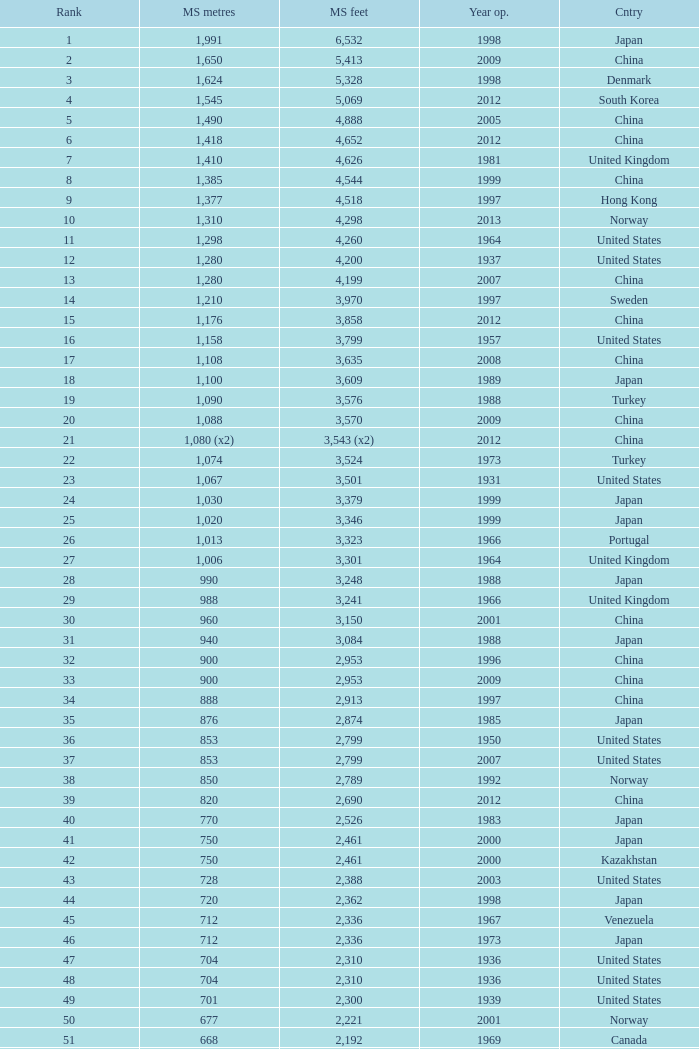Write the full table. {'header': ['Rank', 'MS metres', 'MS feet', 'Year op.', 'Cntry'], 'rows': [['1', '1,991', '6,532', '1998', 'Japan'], ['2', '1,650', '5,413', '2009', 'China'], ['3', '1,624', '5,328', '1998', 'Denmark'], ['4', '1,545', '5,069', '2012', 'South Korea'], ['5', '1,490', '4,888', '2005', 'China'], ['6', '1,418', '4,652', '2012', 'China'], ['7', '1,410', '4,626', '1981', 'United Kingdom'], ['8', '1,385', '4,544', '1999', 'China'], ['9', '1,377', '4,518', '1997', 'Hong Kong'], ['10', '1,310', '4,298', '2013', 'Norway'], ['11', '1,298', '4,260', '1964', 'United States'], ['12', '1,280', '4,200', '1937', 'United States'], ['13', '1,280', '4,199', '2007', 'China'], ['14', '1,210', '3,970', '1997', 'Sweden'], ['15', '1,176', '3,858', '2012', 'China'], ['16', '1,158', '3,799', '1957', 'United States'], ['17', '1,108', '3,635', '2008', 'China'], ['18', '1,100', '3,609', '1989', 'Japan'], ['19', '1,090', '3,576', '1988', 'Turkey'], ['20', '1,088', '3,570', '2009', 'China'], ['21', '1,080 (x2)', '3,543 (x2)', '2012', 'China'], ['22', '1,074', '3,524', '1973', 'Turkey'], ['23', '1,067', '3,501', '1931', 'United States'], ['24', '1,030', '3,379', '1999', 'Japan'], ['25', '1,020', '3,346', '1999', 'Japan'], ['26', '1,013', '3,323', '1966', 'Portugal'], ['27', '1,006', '3,301', '1964', 'United Kingdom'], ['28', '990', '3,248', '1988', 'Japan'], ['29', '988', '3,241', '1966', 'United Kingdom'], ['30', '960', '3,150', '2001', 'China'], ['31', '940', '3,084', '1988', 'Japan'], ['32', '900', '2,953', '1996', 'China'], ['33', '900', '2,953', '2009', 'China'], ['34', '888', '2,913', '1997', 'China'], ['35', '876', '2,874', '1985', 'Japan'], ['36', '853', '2,799', '1950', 'United States'], ['37', '853', '2,799', '2007', 'United States'], ['38', '850', '2,789', '1992', 'Norway'], ['39', '820', '2,690', '2012', 'China'], ['40', '770', '2,526', '1983', 'Japan'], ['41', '750', '2,461', '2000', 'Japan'], ['42', '750', '2,461', '2000', 'Kazakhstan'], ['43', '728', '2,388', '2003', 'United States'], ['44', '720', '2,362', '1998', 'Japan'], ['45', '712', '2,336', '1967', 'Venezuela'], ['46', '712', '2,336', '1973', 'Japan'], ['47', '704', '2,310', '1936', 'United States'], ['48', '704', '2,310', '1936', 'United States'], ['49', '701', '2,300', '1939', 'United States'], ['50', '677', '2,221', '2001', 'Norway'], ['51', '668', '2,192', '1969', 'Canada'], ['52', '656', '2,152', '1968', 'United States'], ['53', '656', '2152', '1951', 'United States'], ['54', '648', '2,126', '1999', 'China'], ['55', '636', '2,087', '2009', 'China'], ['56', '623', '2,044', '1992', 'Norway'], ['57', '616', '2,021', '2009', 'China'], ['58', '610', '2,001', '1957', 'United States'], ['59', '608', '1,995', '1959', 'France'], ['60', '600', '1,969', '1970', 'Denmark'], ['61', '600', '1,969', '1999', 'Japan'], ['62', '600', '1,969', '2000', 'China'], ['63', '595', '1,952', '1997', 'Norway'], ['64', '580', '1,903', '2003', 'China'], ['65', '577', '1,893', '2001', 'Norway'], ['66', '570', '1,870', '1993', 'Japan'], ['67', '564', '1,850', '1929', 'United States Canada'], ['68', '560', '1,837', '1988', 'Japan'], ['69', '560', '1,837', '2001', 'China'], ['70', '549', '1,801', '1961', 'United States'], ['71', '540', '1,772', '2008', 'Japan'], ['72', '534', '1,752', '1926', 'United States'], ['73', '525', '1,722', '1972', 'Norway'], ['74', '525', '1,722', '1977', 'Norway'], ['75', '520', '1,706', '1983', 'Democratic Republic of the Congo'], ['76', '500', '1,640', '1965', 'Germany'], ['77', '500', '1,640', '2002', 'South Korea'], ['78', '497', '1,631', '1924', 'United States'], ['79', '488', '1,601', '1903', 'United States'], ['80', '488', '1,601', '1969', 'United States'], ['81', '488', '1,601', '1952', 'United States'], ['82', '488', '1,601', '1973', 'United States'], ['83', '486', '1,594', '1883', 'United States'], ['84', '473', '1,552', '1938', 'Canada'], ['85', '468', '1,535', '1971', 'Norway'], ['86', '465', '1,526', '1977', 'Japan'], ['87', '457', '1,499', '1930', 'United States'], ['88', '457', '1,499', '1963', 'United States'], ['89', '452', '1,483', '1995', 'China'], ['90', '450', '1,476', '1997', 'China'], ['91', '448', '1,470', '1909', 'United States'], ['92', '446', '1,463', '1997', 'Norway'], ['93', '441', '1,447', '1955', 'Canada'], ['94', '430', '1,411', '2012', 'China'], ['95', '427', '1,401', '1970', 'Canada'], ['96', '421', '1,381', '1936', 'United States'], ['97', '417', '1,368', '1966', 'Sweden'], ['98', '408', '1339', '2010', 'China'], ['99', '405', '1,329', '2009', 'Vietnam'], ['100', '404', '1,325', '1973', 'South Korea'], ['101', '394', '1,293', '1967', 'France'], ['102', '390', '1,280', '1964', 'Uzbekistan'], ['103', '385', '1,263', '2013', 'United States'], ['104', '378', '1,240', '1954', 'Germany'], ['105', '368', '1,207', '1931', 'United States'], ['106', '367', '1,204', '1962', 'Japan'], ['107', '366', '1,200', '1929', 'United States'], ['108', '351', '1,151', '1960', 'United States Canada'], ['109', '350', '1,148', '2006', 'China'], ['110', '340', '1,115', '1926', 'Brazil'], ['111', '338', '1,109', '2001', 'China'], ['112', '338', '1,108', '1965', 'United States'], ['113', '337', '1,106', '1956', 'Norway'], ['114', '335', '1,100', '1961', 'United Kingdom'], ['115', '335', '1,100', '2006', 'Norway'], ['116', '329', '1,088', '1939', 'United States'], ['117', '328', '1,085', '1939', 'Zambia Zimbabwe'], ['118', '325', '1,066', '1964', 'Norway'], ['119', '325', '1,066', '1981', 'Norway'], ['120', '323', '1,060', '1932', 'United States'], ['121', '323', '1,059', '1936', 'Canada'], ['122', '322', '1,057', '1867', 'United States'], ['123', '320', '1,050', '1971', 'United States'], ['124', '320', '1,050', '2011', 'Peru'], ['125', '315', '1,033', '1951', 'Germany'], ['126', '308', '1,010', '1849', 'United States'], ['127', '300', '985', '1961', 'Canada'], ['128', '300', '984', '1987', 'Japan'], ['129', '300', '984', '2000', 'France'], ['130', '300', '984', '2000', 'South Korea']]} In south korea, which is the earliest year featuring a main span of 1,640 feet? 2002.0. 